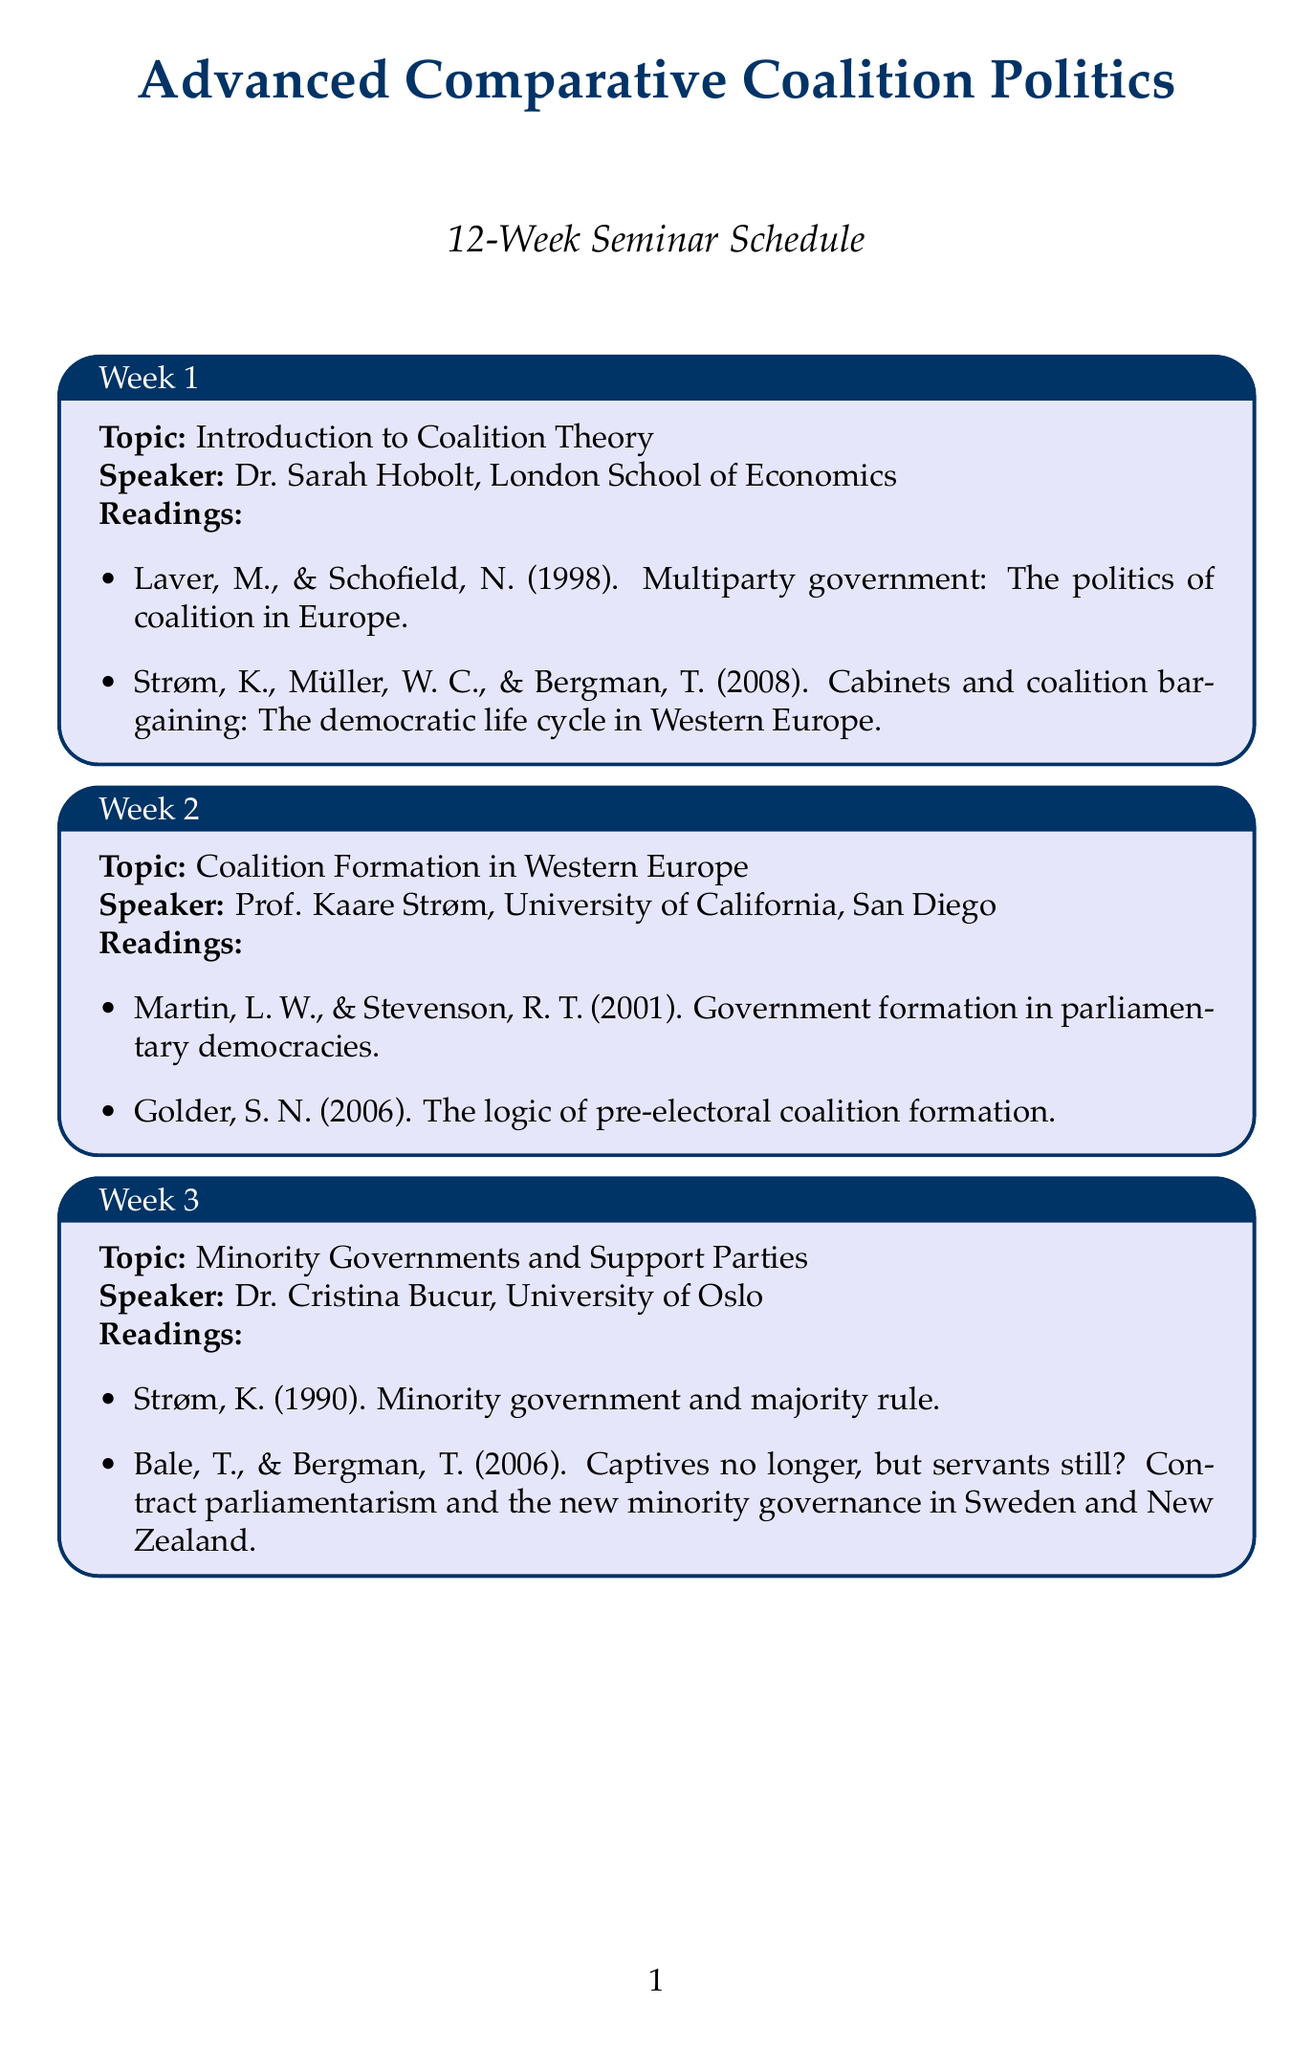What is the title of the seminar? The title of the seminar is provided at the beginning of the document.
Answer: Advanced Comparative Coalition Politics Who is the speaker for Week 5? The speaker for Week 5 is mentioned along with the topic for that week.
Answer: Dr. Sona Golder, Pennsylvania State University What is the topic for Week 8? The topic for Week 8 is stated explicitly in the schedule.
Answer: Coalition Dynamics in Italy and Spain How many weeks does the seminar last? The total duration of the seminar is found in the introduction.
Answer: 12 weeks What reading is required for coalition formation in Western Europe? The required reading is listed under the specific week's topic and speaker.
Answer: Martin, L. W., & Stevenson, R. T. (2001). Government formation in parliamentary democracies Which university is Prof. Bonnie N. Field associated with? This information is found next to the speaker's name for Week 12.
Answer: Bentley University What is the focus of Week 10? The focus for Week 10 is indicated by the topic listed for that week.
Answer: Coalition Politics in Israel What is the primary theme for Week 6? The theme is found in the week's title in the document.
Answer: Comparative Coalition Politics in Scandinavia List one of the readings for Week 3. The readings for Week 3 can be extracted directly from the document.
Answer: Strøm, K. (1990). Minority government and majority rule 